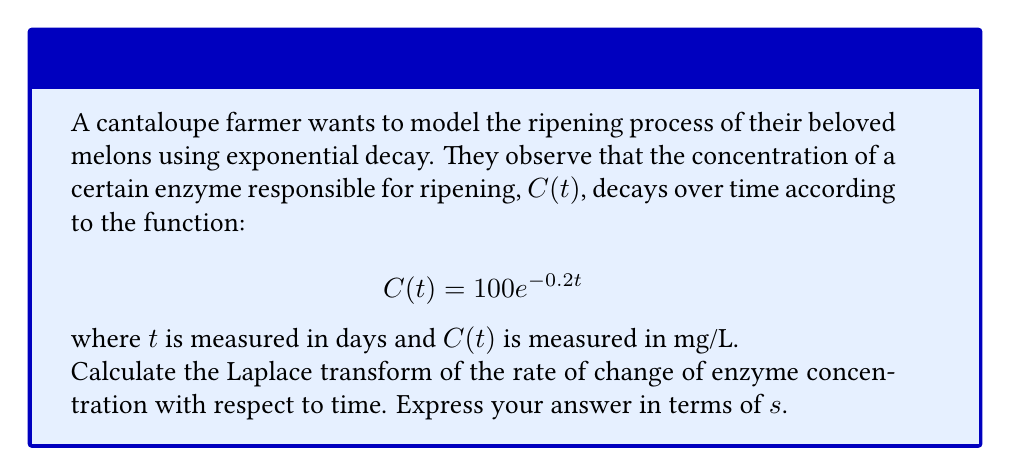Give your solution to this math problem. Let's approach this step-by-step:

1) First, we need to find the rate of change of the enzyme concentration. This is the derivative of $C(t)$ with respect to $t$:

   $$\frac{dC}{dt} = -20e^{-0.2t}$$

2) Now, we need to find the Laplace transform of this function. The Laplace transform is defined as:

   $$\mathcal{L}\{f(t)\} = F(s) = \int_0^\infty e^{-st}f(t)dt$$

3) In our case, $f(t) = -20e^{-0.2t}$, so we need to calculate:

   $$\mathcal{L}\{-20e^{-0.2t}\} = -20\int_0^\infty e^{-st}e^{-0.2t}dt$$

4) We can simplify the integrand:

   $$-20\int_0^\infty e^{-(s+0.2)t}dt$$

5) This is a standard integral. The solution is:

   $$-20 \left[-\frac{1}{s+0.2}e^{-(s+0.2)t}\right]_0^\infty$$

6) Evaluating the limits:

   $$-20 \left(0 - \left(-\frac{1}{s+0.2}\right)\right) = \frac{20}{s+0.2}$$

Therefore, the Laplace transform of the rate of change of enzyme concentration is $\frac{20}{s+0.2}$.
Answer: $\frac{20}{s+0.2}$ 